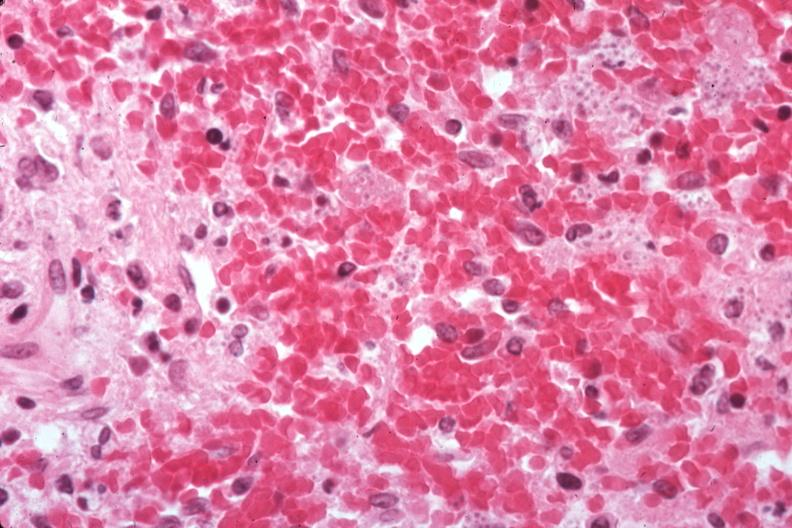does atrophy show organisms easily seen?
Answer the question using a single word or phrase. No 